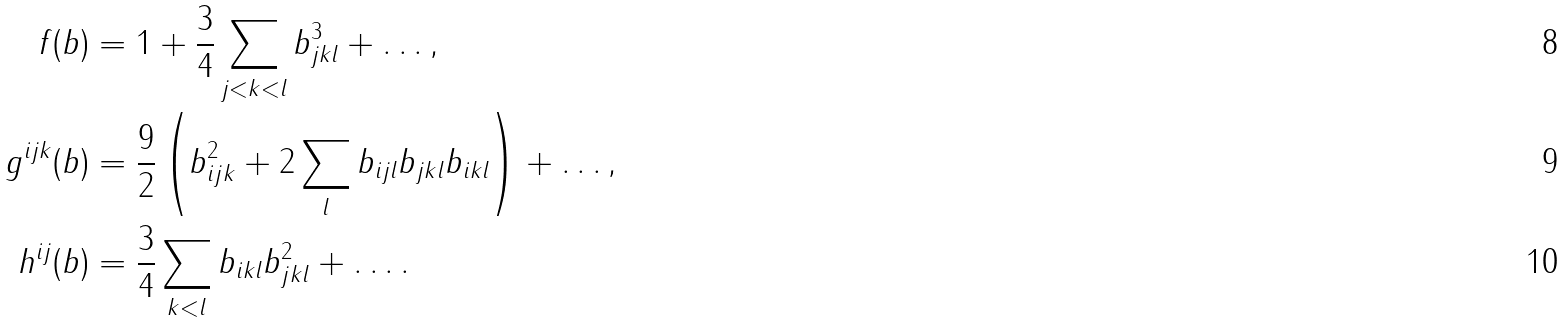Convert formula to latex. <formula><loc_0><loc_0><loc_500><loc_500>f ( b ) & = 1 + \frac { 3 } { 4 } \sum _ { j < k < l } b _ { j k l } ^ { 3 } + \dots , \\ g ^ { i j k } ( b ) & = \frac { 9 } { 2 } \left ( b _ { i j k } ^ { 2 } + 2 \sum _ { l } b _ { i j l } b _ { j k l } b _ { i k l } \right ) + \dots , \\ h ^ { i j } ( b ) & = \frac { 3 } { 4 } \sum _ { k < l } b _ { i k l } b _ { j k l } ^ { 2 } + \dots .</formula> 